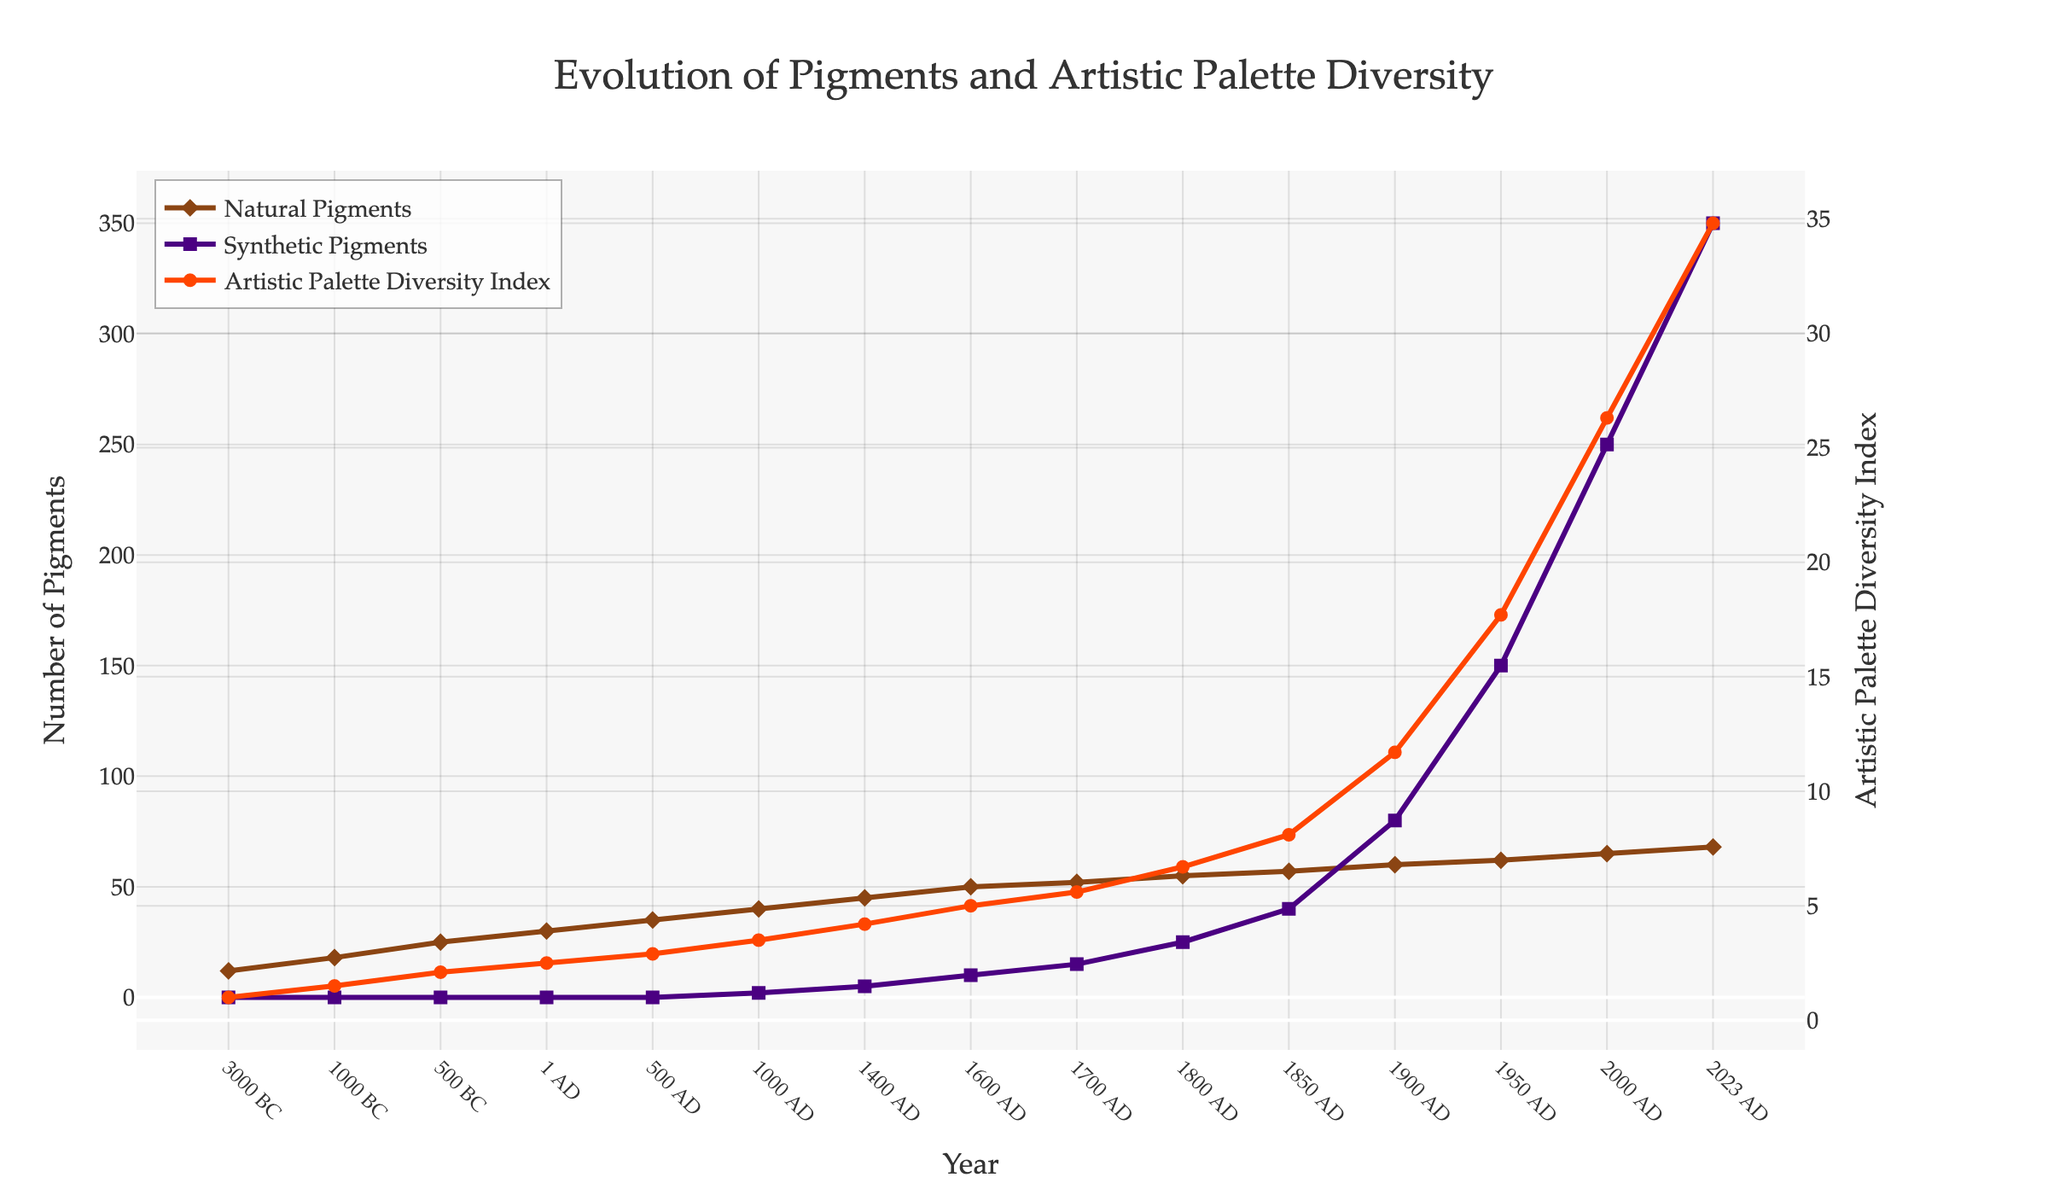What year did synthetic pigments first appear in the data? Look at the x-axis and the corresponding plot points for synthetic pigments. The first appearance is in 1000 AD.
Answer: 1000 AD How does the Artistic Palette Diversity Index in 2000 AD compare to that in 1950 AD? Check the values of the Artistic Palette Diversity Index for the years 2000 AD and 1950 AD. The value in 2000 AD is 26.3, and in 1950 AD it is 17.7. The index increased from 1950 AD to 2000 AD.
Answer: It increased What is the sum of natural pigments and synthetic pigments in the year 1800 AD? Find the values of natural pigments and synthetic pigments in 1800 AD from the chart. Natural pigments = 55, Synthetic pigments = 25. Sum them up: 55 + 25 = 80.
Answer: 80 Identify the period with the most significant growth in synthetic pigments. Look at the slope of the synthetic pigments line over different periods. The most significant growth appears to be between 1900 AD and 1950 AD, where it jumps from 80 to 150.
Answer: 1900 AD to 1950 AD By how much did the Total Available Colors increase between 1400 AD and 1600 AD? Find the total available colors in 1400 AD (50) and in 1600 AD (60). Calculate the difference: 60 - 50 = 10.
Answer: 10 What can we observe about the relationship between the number of synthetic pigments and the Artistic Palette Diversity Index after 1800 AD? After 1800 AD, both the number of synthetic pigments and the Artistic Palette Diversity Index show a strong upward trend, indicating that the introduction of more synthetic pigments contributes significantly to the diversity index.
Answer: Both increased significantly Which type of pigments (natural or synthetic) had a larger contribution to the Total Available Colors in 2023 AD? In 2023 AD, natural pigments = 68 and synthetic pigments = 350. Synthetic pigments contribute much more to the total available colors.
Answer: Synthetic pigments When did both natural pigments and the Artistic Palette Diversity Index each reach a value of 50 or higher? Look for the first year where each of these values reaches or exceeds 50. For natural pigments, it's 1600 AD (50) and for the Artistic Palette Diversity Index, it's 1600 AD (5.0).
Answer: 1600 AD How many years did it take for the Artistic Palette Diversity Index to increase from approximately 5 to approximately 10? Observe the years where the Index was close to 5 and 10. Around 1600 AD, the index was 5 and around 1850 AD, it approached 10 (8.1). So, it took around 250 years.
Answer: Around 250 years 